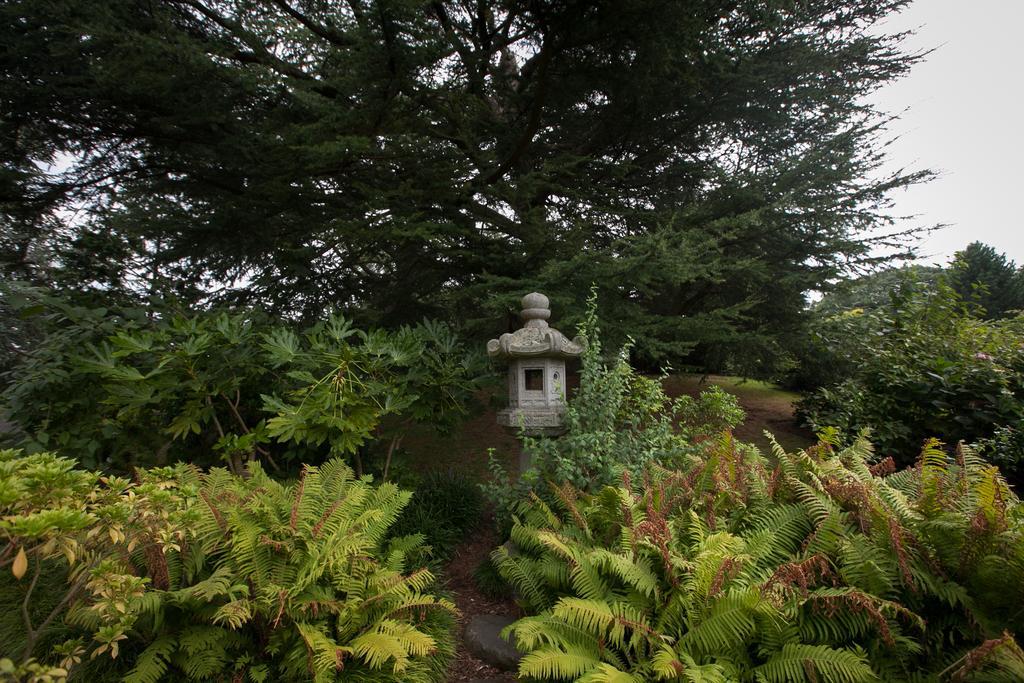Please provide a concise description of this image. In this picture I can see number of trees and plants and in the middle of this picture I see a white color thing and in the background I see the sky. 